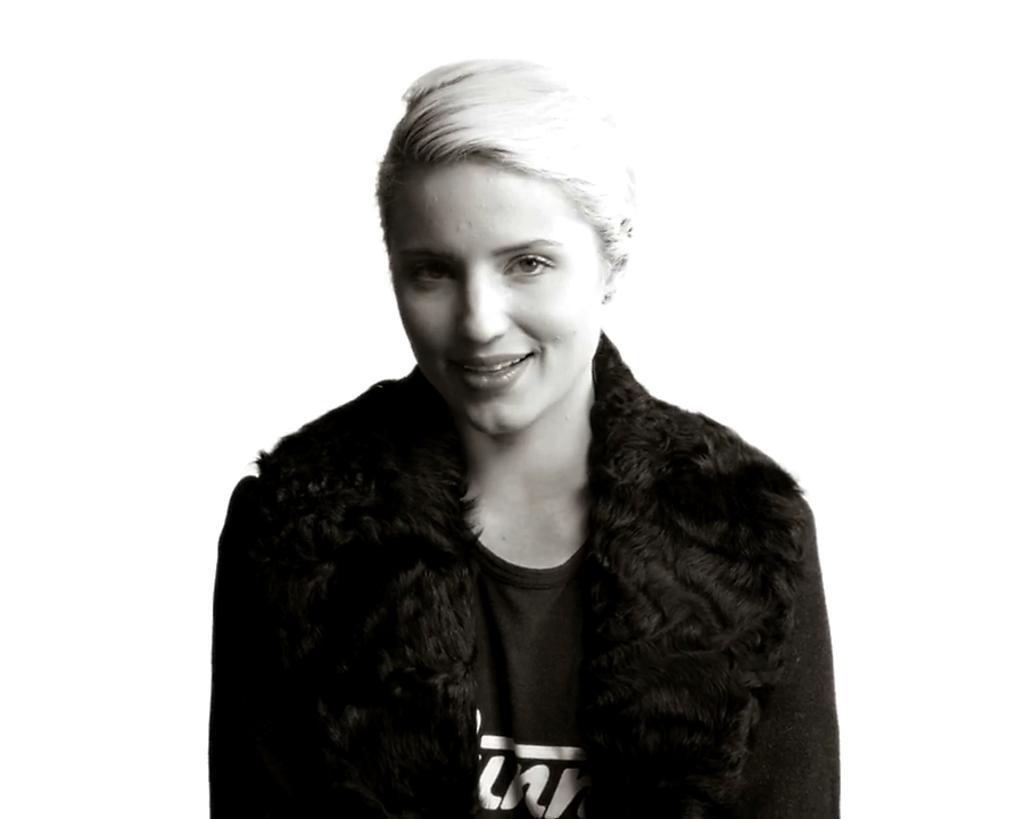Please provide a concise description of this image. It is a black and white picture of a woman, she wore t-shirt, coat and also smiling. 